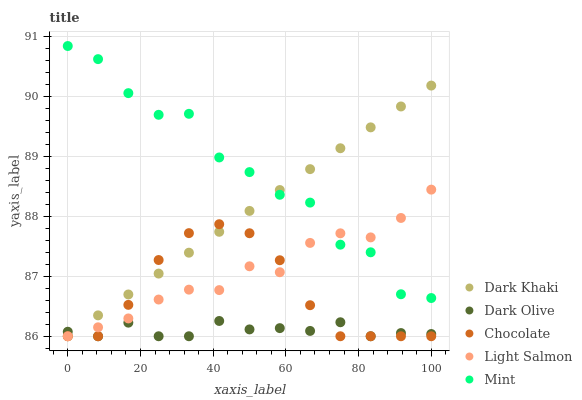Does Dark Olive have the minimum area under the curve?
Answer yes or no. Yes. Does Mint have the maximum area under the curve?
Answer yes or no. Yes. Does Light Salmon have the minimum area under the curve?
Answer yes or no. No. Does Light Salmon have the maximum area under the curve?
Answer yes or no. No. Is Dark Khaki the smoothest?
Answer yes or no. Yes. Is Mint the roughest?
Answer yes or no. Yes. Is Light Salmon the smoothest?
Answer yes or no. No. Is Light Salmon the roughest?
Answer yes or no. No. Does Dark Khaki have the lowest value?
Answer yes or no. Yes. Does Mint have the lowest value?
Answer yes or no. No. Does Mint have the highest value?
Answer yes or no. Yes. Does Light Salmon have the highest value?
Answer yes or no. No. Is Dark Olive less than Mint?
Answer yes or no. Yes. Is Mint greater than Dark Olive?
Answer yes or no. Yes. Does Chocolate intersect Light Salmon?
Answer yes or no. Yes. Is Chocolate less than Light Salmon?
Answer yes or no. No. Is Chocolate greater than Light Salmon?
Answer yes or no. No. Does Dark Olive intersect Mint?
Answer yes or no. No. 